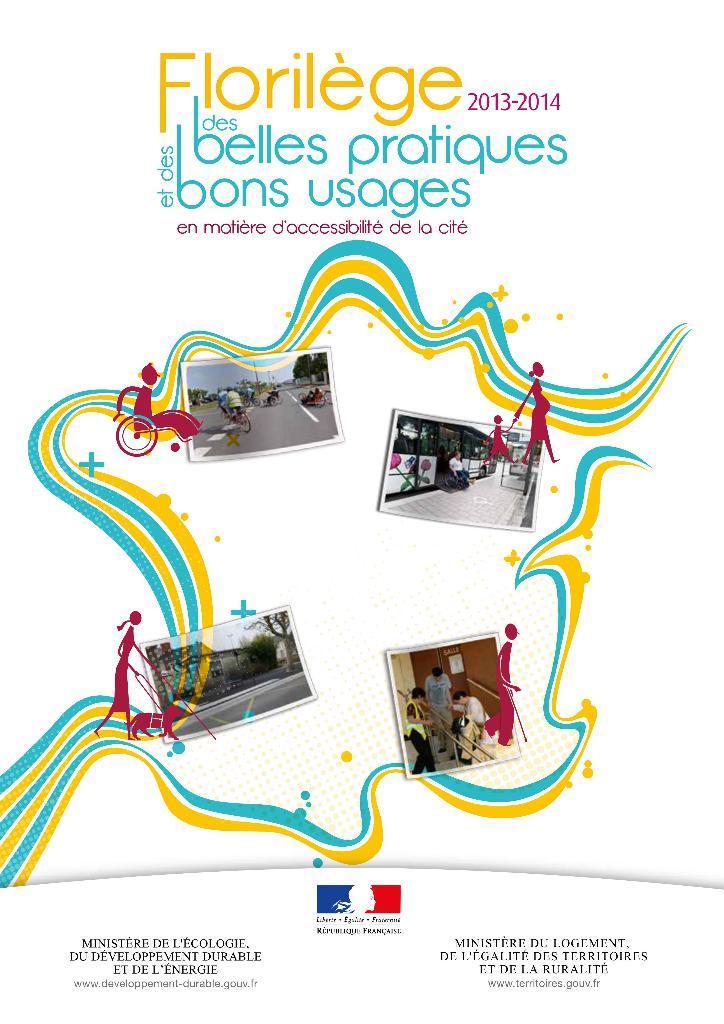In one or two sentences, can you explain what this image depicts? In this image, we can see a poster with some images and text. 